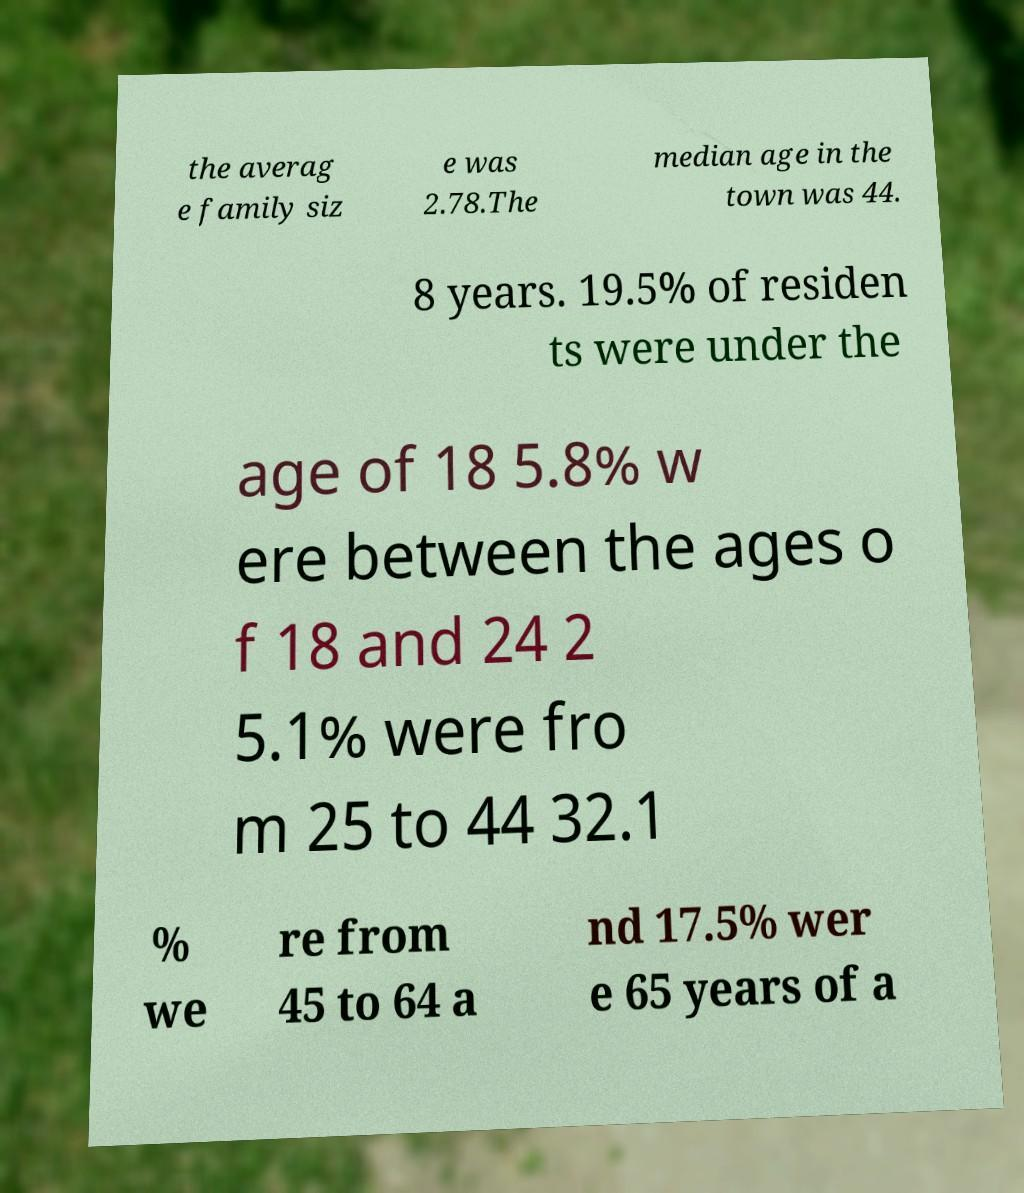What messages or text are displayed in this image? I need them in a readable, typed format. the averag e family siz e was 2.78.The median age in the town was 44. 8 years. 19.5% of residen ts were under the age of 18 5.8% w ere between the ages o f 18 and 24 2 5.1% were fro m 25 to 44 32.1 % we re from 45 to 64 a nd 17.5% wer e 65 years of a 